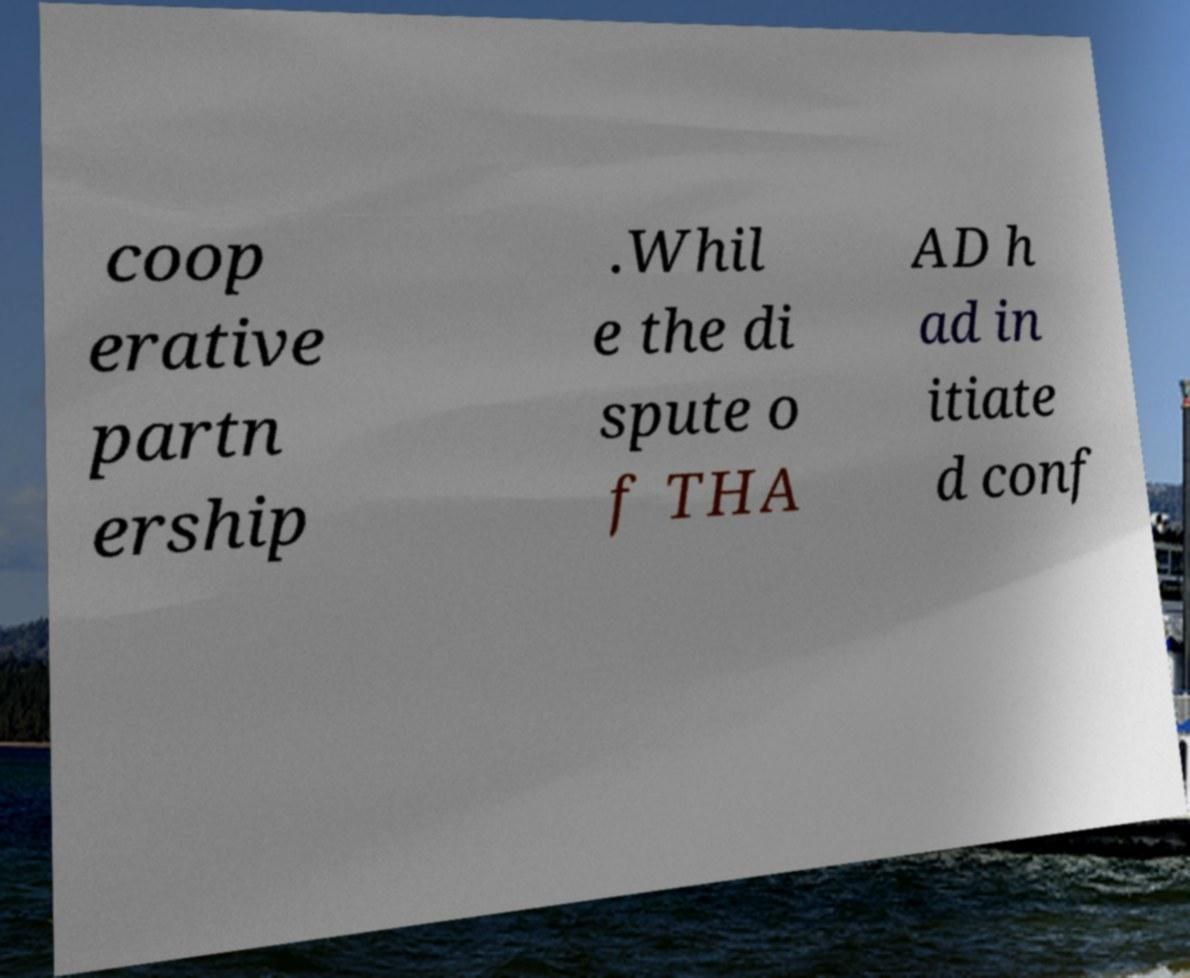Can you accurately transcribe the text from the provided image for me? coop erative partn ership .Whil e the di spute o f THA AD h ad in itiate d conf 